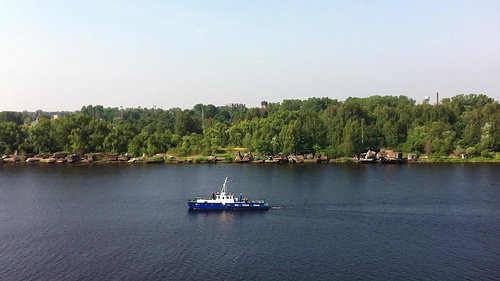Please provide the bounding box coordinate of the region this sentence describes: Trees in the bank of river. The densely packed green trees on the riverbank span from [0.01, 0.4, 0.99, 0.54], offering a lush, scenic view along the water's edge. 